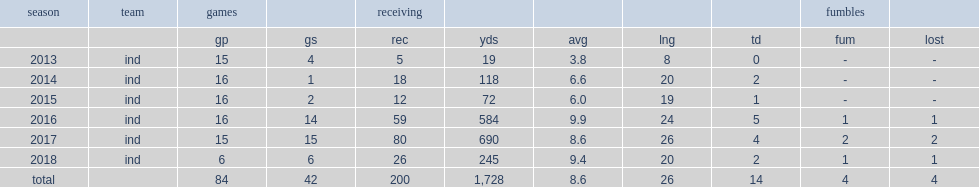How many receptions did doyle get in 2016? 59.0. Would you be able to parse every entry in this table? {'header': ['season', 'team', 'games', '', 'receiving', '', '', '', '', 'fumbles', ''], 'rows': [['', '', 'gp', 'gs', 'rec', 'yds', 'avg', 'lng', 'td', 'fum', 'lost'], ['2013', 'ind', '15', '4', '5', '19', '3.8', '8', '0', '-', '-'], ['2014', 'ind', '16', '1', '18', '118', '6.6', '20', '2', '-', '-'], ['2015', 'ind', '16', '2', '12', '72', '6.0', '19', '1', '-', '-'], ['2016', 'ind', '16', '14', '59', '584', '9.9', '24', '5', '1', '1'], ['2017', 'ind', '15', '15', '80', '690', '8.6', '26', '4', '2', '2'], ['2018', 'ind', '6', '6', '26', '245', '9.4', '20', '2', '1', '1'], ['total', '', '84', '42', '200', '1,728', '8.6', '26', '14', '4', '4']]} 